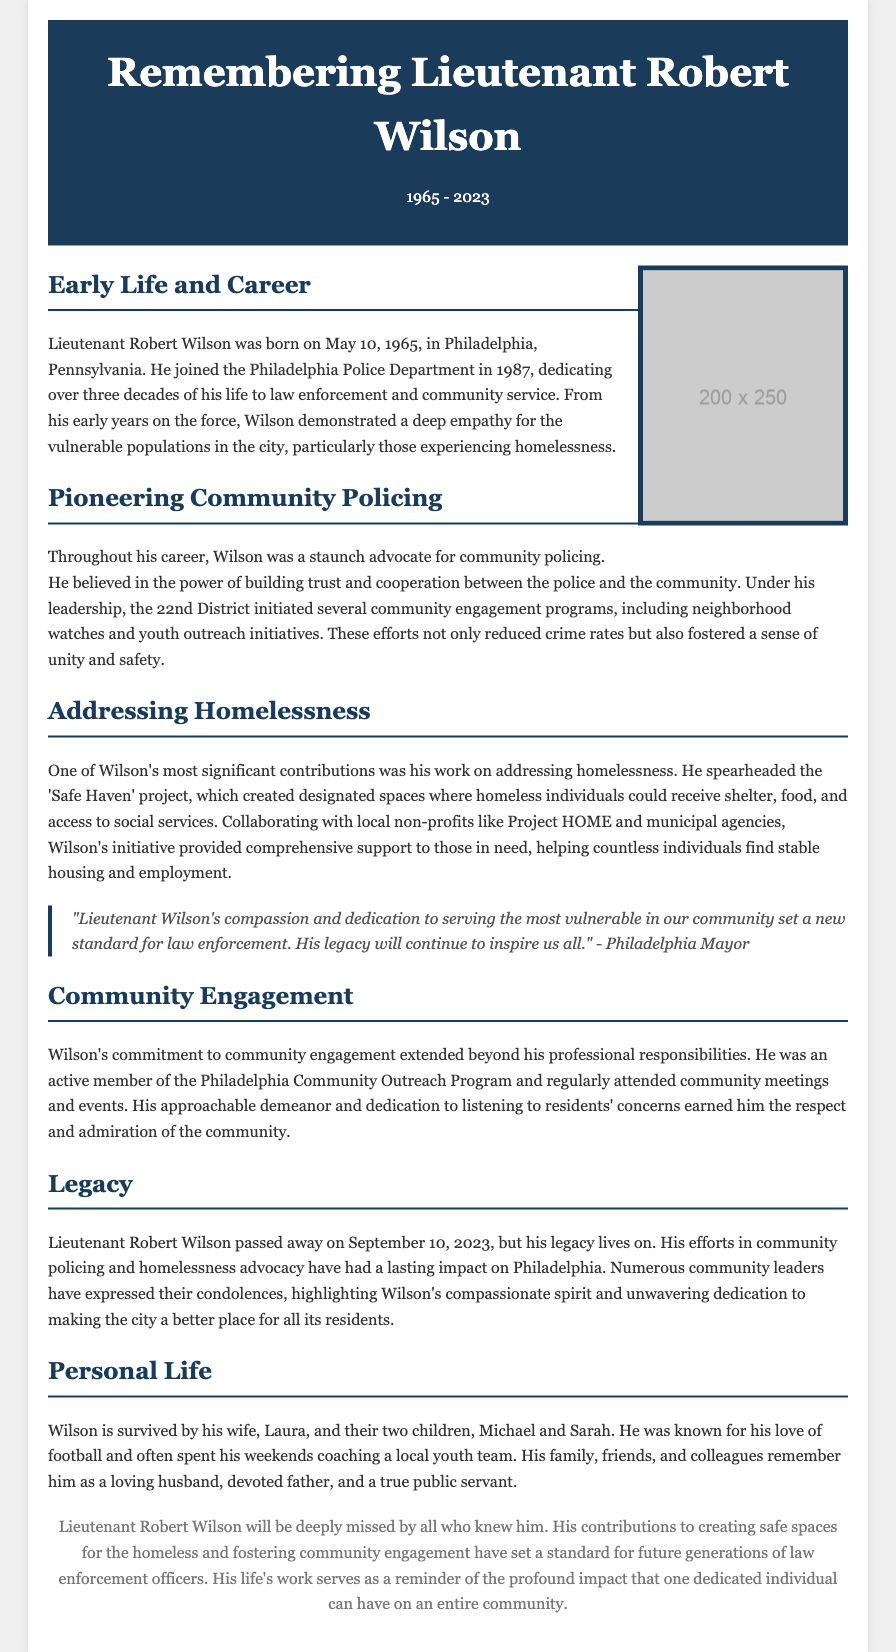What is the birth date of Lieutenant Robert Wilson? The document states that he was born on May 10, 1965.
Answer: May 10, 1965 What project did Wilson spearhead to address homelessness? The obituary mentions the 'Safe Haven' project as Wilson's initiative for helping the homeless.
Answer: Safe Haven How long did Lieutenant Wilson serve in law enforcement? The document indicates he dedicated over three decades to law enforcement.
Answer: Over three decades Which city was Lieutenant Robert Wilson primarily associated with? The document clearly states that he was part of the Philadelphia Police Department and worked in Philadelphia.
Answer: Philadelphia What was one of Wilson's roles in community policing? He was a staunch advocate and demonstrated deep empathy, emphasizing trust and cooperation with the community.
Answer: Advocate for community policing What organization did Wilson collaborate with to provide support for the homeless? The text specifies collaboration with local non-profits like Project HOME.
Answer: Project HOME What is noted about Lieutenant Wilson's personal life? The document mentions that he is survived by his wife, Laura, and their two children, Michael and Sarah.
Answer: Laura, Michael, and Sarah When did Lieutenant Robert Wilson pass away? The obituary states that he passed away on September 10, 2023.
Answer: September 10, 2023 What were the community engagement efforts initiated under Wilson's leadership? The document lists neighborhood watches and youth outreach initiatives as part of Wilson's community engagement programs.
Answer: Neighborhood watches and youth outreach initiatives 